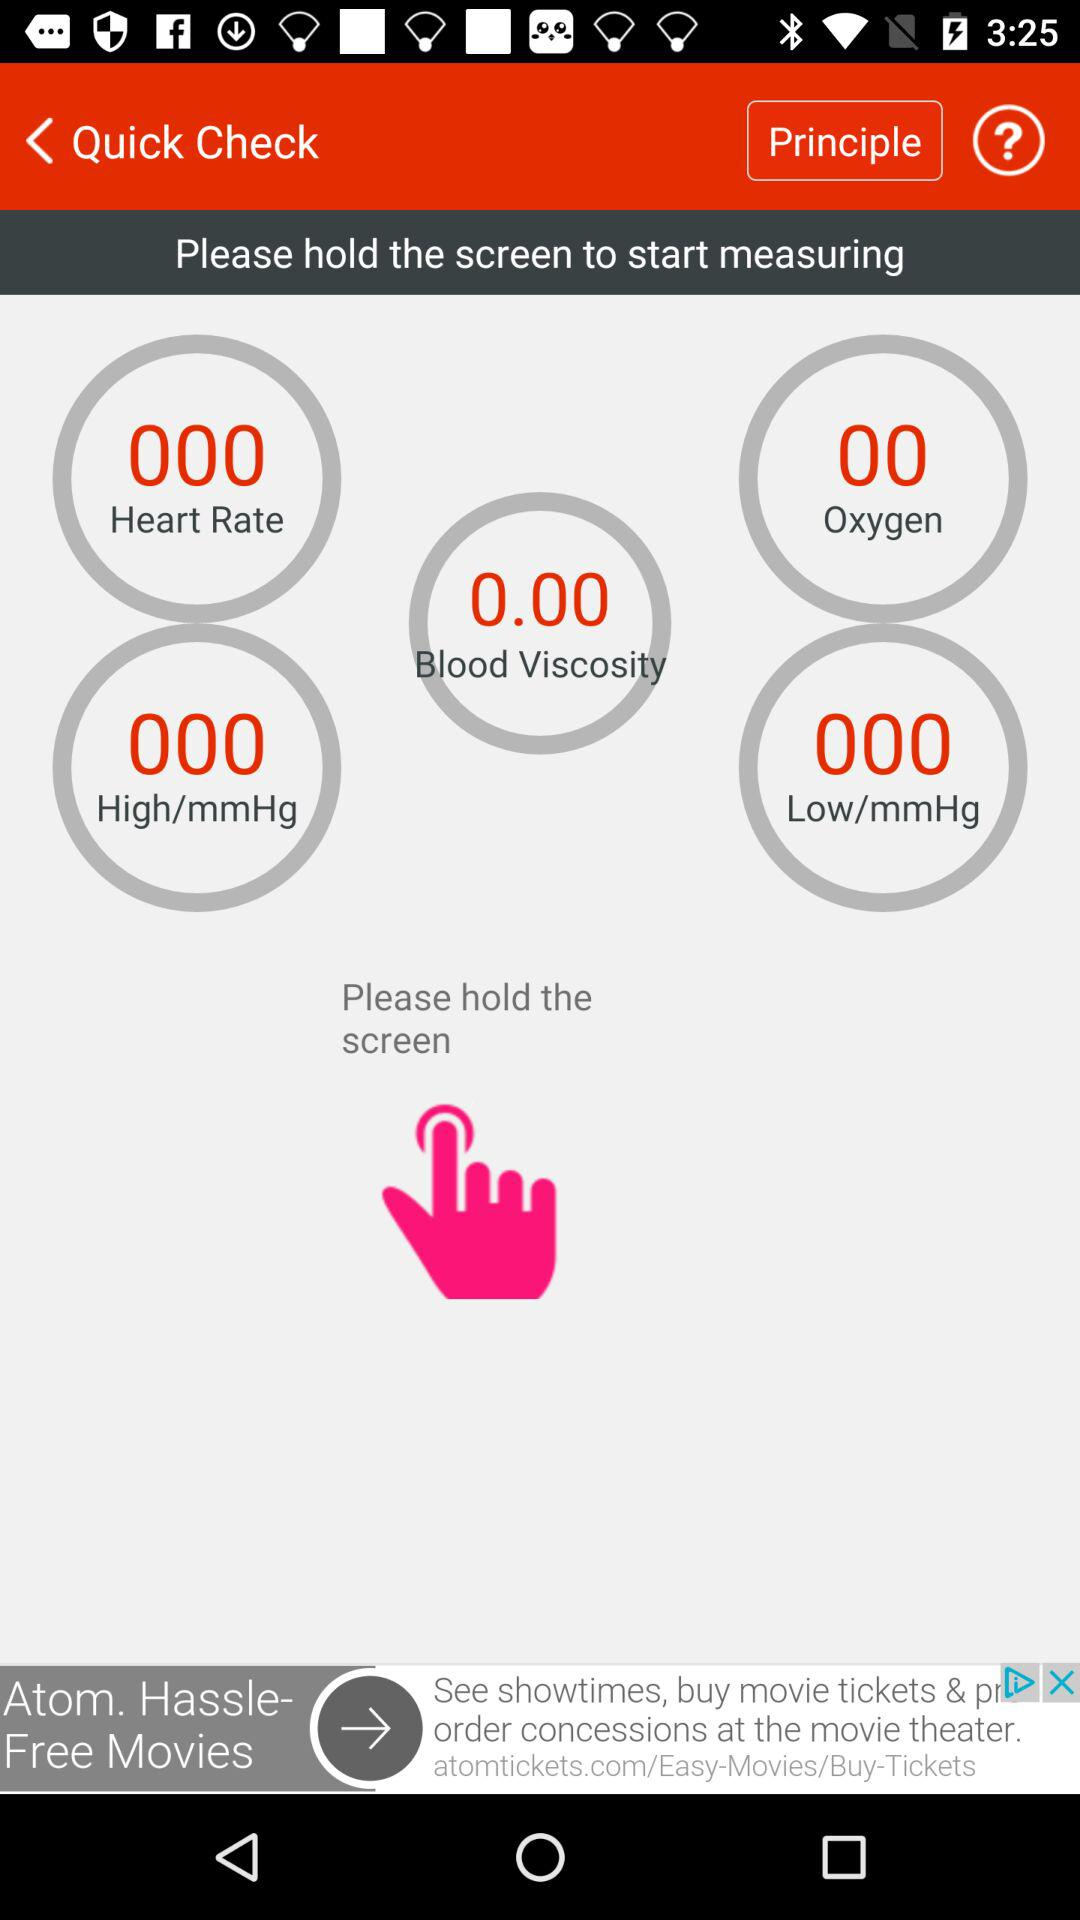What is the value of oxygen? The value of oxygen is 0. 